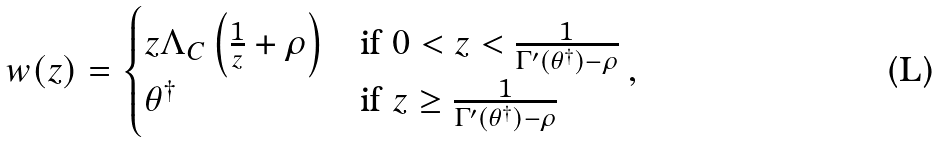Convert formula to latex. <formula><loc_0><loc_0><loc_500><loc_500>w ( z ) = \begin{cases} z \Lambda _ { C } \left ( \frac { 1 } { z } + \rho \right ) & \text {if $0<z<\frac{1}{\Gamma^{\prime}(\theta^{\dagger})-\rho}$} \\ \theta ^ { \dagger } & \text {if $z\geq\frac{1}{\Gamma^{\prime}(\theta^{\dagger})-\rho}$} \end{cases} ,</formula> 